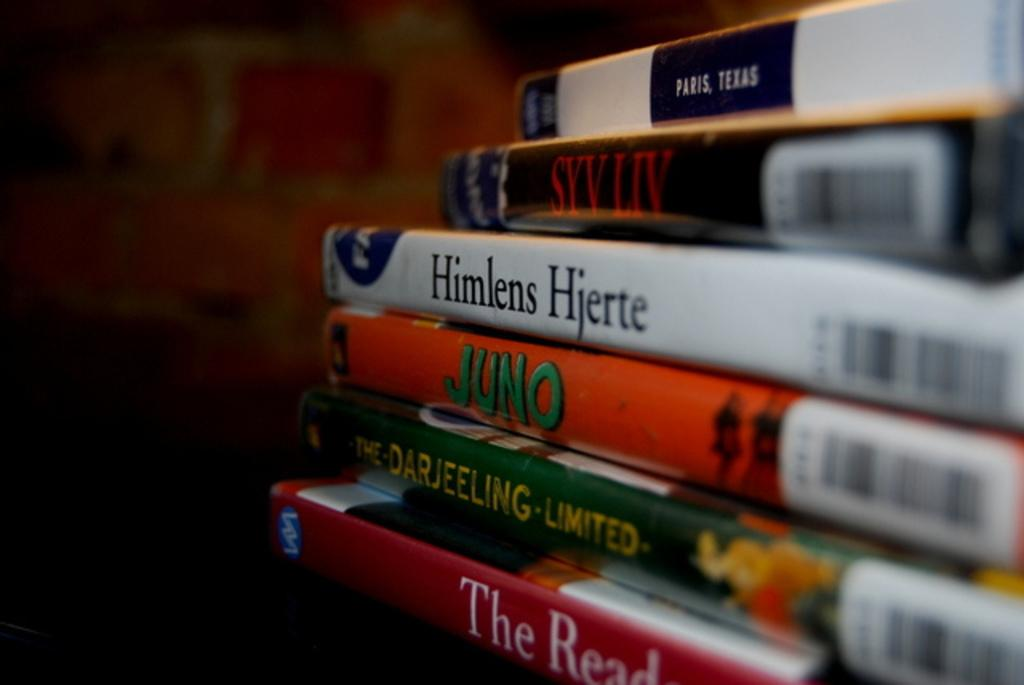<image>
Relay a brief, clear account of the picture shown. A movie titled Juno and Himlens Hjerte that is on DVD. 